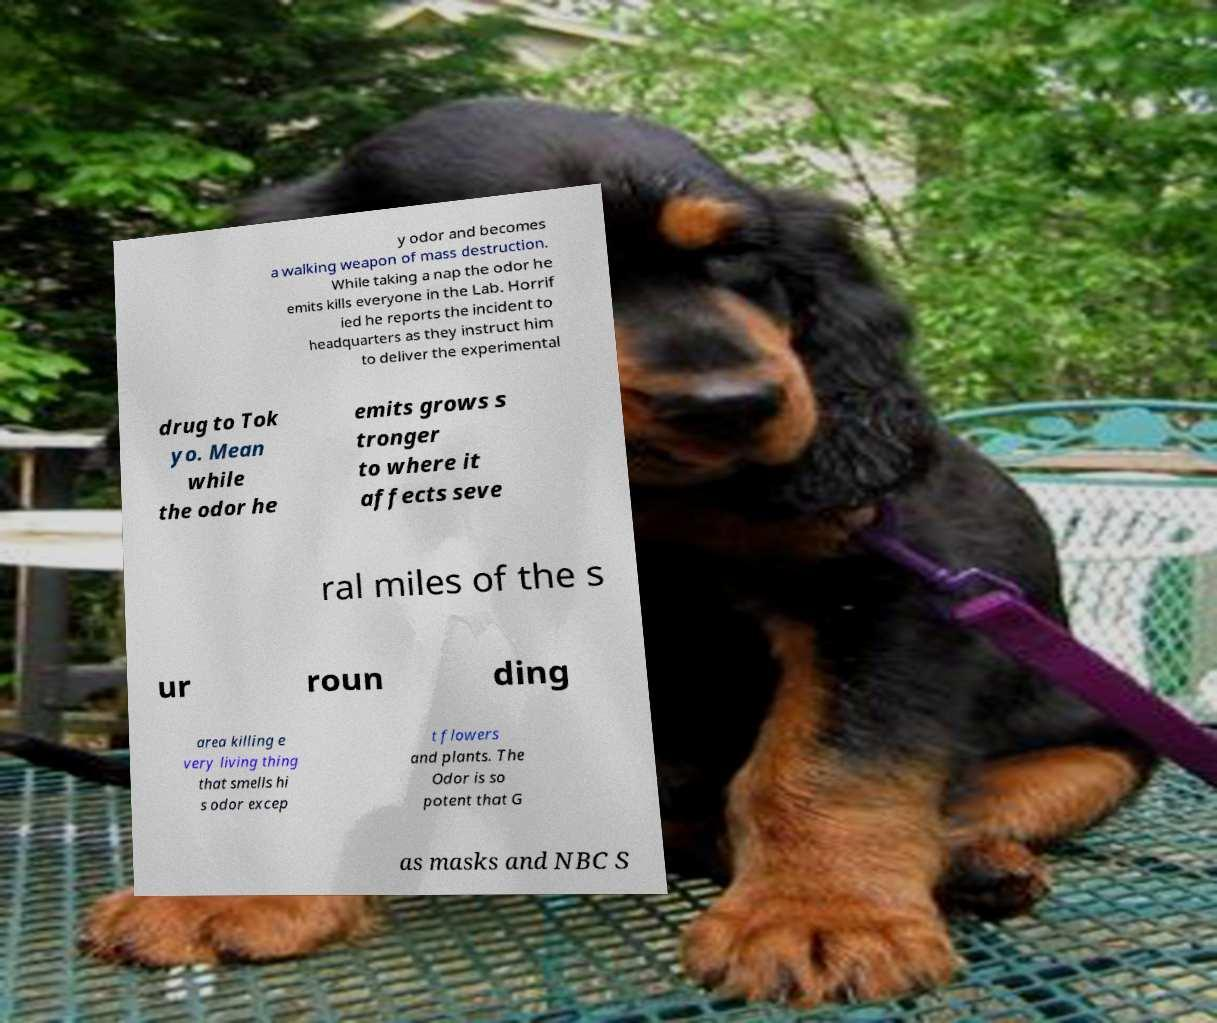For documentation purposes, I need the text within this image transcribed. Could you provide that? y odor and becomes a walking weapon of mass destruction. While taking a nap the odor he emits kills everyone in the Lab. Horrif ied he reports the incident to headquarters as they instruct him to deliver the experimental drug to Tok yo. Mean while the odor he emits grows s tronger to where it affects seve ral miles of the s ur roun ding area killing e very living thing that smells hi s odor excep t flowers and plants. The Odor is so potent that G as masks and NBC S 